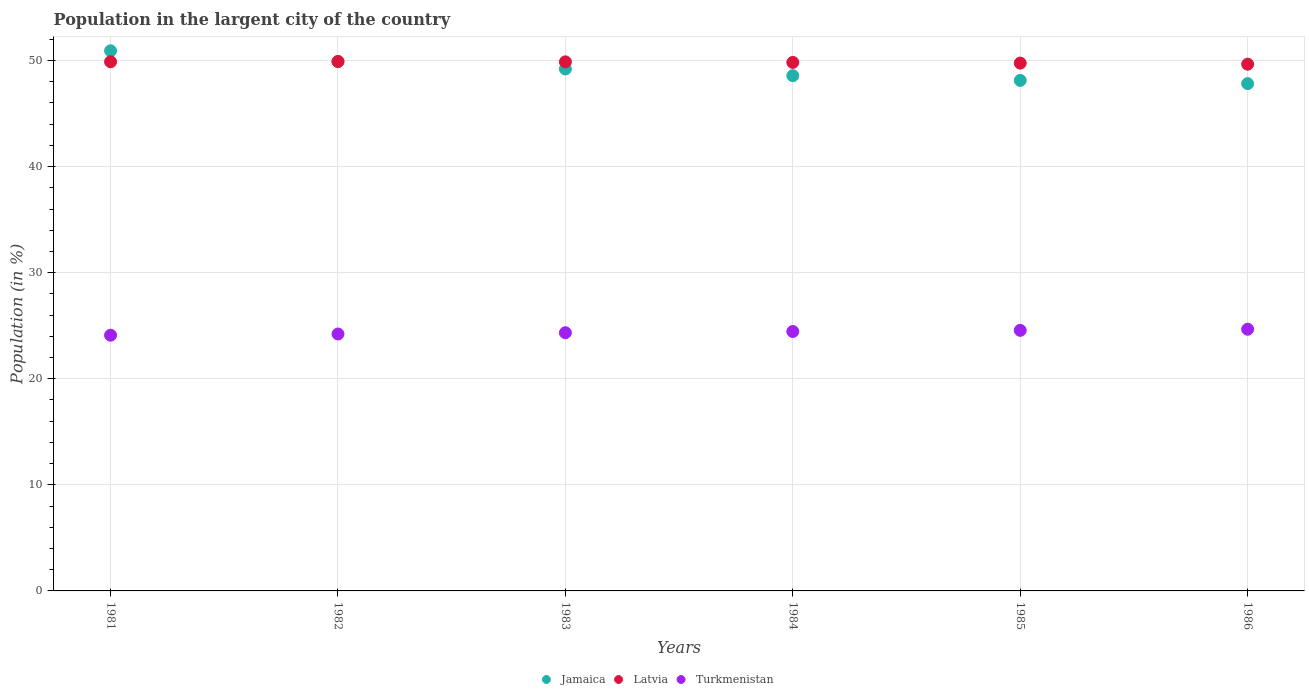How many different coloured dotlines are there?
Offer a terse response. 3. Is the number of dotlines equal to the number of legend labels?
Your response must be concise. Yes. What is the percentage of population in the largent city in Jamaica in 1986?
Offer a very short reply. 47.83. Across all years, what is the maximum percentage of population in the largent city in Turkmenistan?
Give a very brief answer. 24.67. Across all years, what is the minimum percentage of population in the largent city in Turkmenistan?
Provide a succinct answer. 24.11. What is the total percentage of population in the largent city in Latvia in the graph?
Give a very brief answer. 298.92. What is the difference between the percentage of population in the largent city in Turkmenistan in 1983 and that in 1986?
Give a very brief answer. -0.33. What is the difference between the percentage of population in the largent city in Jamaica in 1983 and the percentage of population in the largent city in Latvia in 1986?
Your response must be concise. -0.45. What is the average percentage of population in the largent city in Jamaica per year?
Give a very brief answer. 49.09. In the year 1984, what is the difference between the percentage of population in the largent city in Turkmenistan and percentage of population in the largent city in Latvia?
Keep it short and to the point. -25.37. What is the ratio of the percentage of population in the largent city in Jamaica in 1981 to that in 1982?
Give a very brief answer. 1.02. Is the percentage of population in the largent city in Jamaica in 1982 less than that in 1983?
Offer a terse response. No. Is the difference between the percentage of population in the largent city in Turkmenistan in 1983 and 1984 greater than the difference between the percentage of population in the largent city in Latvia in 1983 and 1984?
Provide a short and direct response. No. What is the difference between the highest and the second highest percentage of population in the largent city in Latvia?
Offer a terse response. 0.03. What is the difference between the highest and the lowest percentage of population in the largent city in Jamaica?
Your answer should be very brief. 3.09. In how many years, is the percentage of population in the largent city in Turkmenistan greater than the average percentage of population in the largent city in Turkmenistan taken over all years?
Your answer should be very brief. 3. Is it the case that in every year, the sum of the percentage of population in the largent city in Jamaica and percentage of population in the largent city in Latvia  is greater than the percentage of population in the largent city in Turkmenistan?
Your answer should be compact. Yes. Does the percentage of population in the largent city in Jamaica monotonically increase over the years?
Your response must be concise. No. Is the percentage of population in the largent city in Jamaica strictly greater than the percentage of population in the largent city in Turkmenistan over the years?
Ensure brevity in your answer.  Yes. How many years are there in the graph?
Your answer should be compact. 6. Are the values on the major ticks of Y-axis written in scientific E-notation?
Your answer should be compact. No. Does the graph contain grids?
Make the answer very short. Yes. Where does the legend appear in the graph?
Your answer should be compact. Bottom center. How many legend labels are there?
Provide a succinct answer. 3. How are the legend labels stacked?
Provide a short and direct response. Horizontal. What is the title of the graph?
Your response must be concise. Population in the largent city of the country. Does "Small states" appear as one of the legend labels in the graph?
Your answer should be very brief. No. What is the label or title of the X-axis?
Your answer should be very brief. Years. What is the Population (in %) in Jamaica in 1981?
Offer a terse response. 50.92. What is the Population (in %) of Latvia in 1981?
Provide a short and direct response. 49.89. What is the Population (in %) in Turkmenistan in 1981?
Keep it short and to the point. 24.11. What is the Population (in %) in Jamaica in 1982?
Keep it short and to the point. 49.9. What is the Population (in %) in Latvia in 1982?
Give a very brief answer. 49.91. What is the Population (in %) in Turkmenistan in 1982?
Give a very brief answer. 24.22. What is the Population (in %) in Jamaica in 1983?
Give a very brief answer. 49.21. What is the Population (in %) in Latvia in 1983?
Ensure brevity in your answer.  49.88. What is the Population (in %) of Turkmenistan in 1983?
Your answer should be very brief. 24.34. What is the Population (in %) in Jamaica in 1984?
Keep it short and to the point. 48.57. What is the Population (in %) in Latvia in 1984?
Keep it short and to the point. 49.82. What is the Population (in %) of Turkmenistan in 1984?
Ensure brevity in your answer.  24.46. What is the Population (in %) of Jamaica in 1985?
Provide a succinct answer. 48.13. What is the Population (in %) of Latvia in 1985?
Your response must be concise. 49.76. What is the Population (in %) of Turkmenistan in 1985?
Your response must be concise. 24.56. What is the Population (in %) of Jamaica in 1986?
Provide a short and direct response. 47.83. What is the Population (in %) of Latvia in 1986?
Offer a terse response. 49.66. What is the Population (in %) in Turkmenistan in 1986?
Offer a terse response. 24.67. Across all years, what is the maximum Population (in %) of Jamaica?
Your answer should be very brief. 50.92. Across all years, what is the maximum Population (in %) in Latvia?
Make the answer very short. 49.91. Across all years, what is the maximum Population (in %) in Turkmenistan?
Keep it short and to the point. 24.67. Across all years, what is the minimum Population (in %) of Jamaica?
Your answer should be compact. 47.83. Across all years, what is the minimum Population (in %) of Latvia?
Ensure brevity in your answer.  49.66. Across all years, what is the minimum Population (in %) in Turkmenistan?
Offer a terse response. 24.11. What is the total Population (in %) of Jamaica in the graph?
Your answer should be very brief. 294.55. What is the total Population (in %) of Latvia in the graph?
Make the answer very short. 298.92. What is the total Population (in %) of Turkmenistan in the graph?
Your answer should be very brief. 146.36. What is the difference between the Population (in %) in Jamaica in 1981 and that in 1982?
Provide a succinct answer. 1.02. What is the difference between the Population (in %) in Latvia in 1981 and that in 1982?
Provide a succinct answer. -0.03. What is the difference between the Population (in %) in Turkmenistan in 1981 and that in 1982?
Offer a very short reply. -0.12. What is the difference between the Population (in %) in Jamaica in 1981 and that in 1983?
Give a very brief answer. 1.71. What is the difference between the Population (in %) of Latvia in 1981 and that in 1983?
Offer a terse response. 0.01. What is the difference between the Population (in %) of Turkmenistan in 1981 and that in 1983?
Provide a succinct answer. -0.23. What is the difference between the Population (in %) of Jamaica in 1981 and that in 1984?
Give a very brief answer. 2.35. What is the difference between the Population (in %) in Latvia in 1981 and that in 1984?
Your answer should be very brief. 0.06. What is the difference between the Population (in %) of Turkmenistan in 1981 and that in 1984?
Your response must be concise. -0.35. What is the difference between the Population (in %) in Jamaica in 1981 and that in 1985?
Keep it short and to the point. 2.79. What is the difference between the Population (in %) of Latvia in 1981 and that in 1985?
Your answer should be very brief. 0.13. What is the difference between the Population (in %) in Turkmenistan in 1981 and that in 1985?
Provide a succinct answer. -0.46. What is the difference between the Population (in %) in Jamaica in 1981 and that in 1986?
Offer a terse response. 3.09. What is the difference between the Population (in %) of Latvia in 1981 and that in 1986?
Offer a very short reply. 0.23. What is the difference between the Population (in %) in Turkmenistan in 1981 and that in 1986?
Give a very brief answer. -0.57. What is the difference between the Population (in %) of Jamaica in 1982 and that in 1983?
Provide a short and direct response. 0.69. What is the difference between the Population (in %) of Latvia in 1982 and that in 1983?
Ensure brevity in your answer.  0.04. What is the difference between the Population (in %) in Turkmenistan in 1982 and that in 1983?
Offer a terse response. -0.12. What is the difference between the Population (in %) of Jamaica in 1982 and that in 1984?
Your response must be concise. 1.33. What is the difference between the Population (in %) in Latvia in 1982 and that in 1984?
Ensure brevity in your answer.  0.09. What is the difference between the Population (in %) of Turkmenistan in 1982 and that in 1984?
Ensure brevity in your answer.  -0.23. What is the difference between the Population (in %) of Jamaica in 1982 and that in 1985?
Your answer should be compact. 1.77. What is the difference between the Population (in %) of Latvia in 1982 and that in 1985?
Your answer should be very brief. 0.15. What is the difference between the Population (in %) in Turkmenistan in 1982 and that in 1985?
Your response must be concise. -0.34. What is the difference between the Population (in %) of Jamaica in 1982 and that in 1986?
Your answer should be very brief. 2.08. What is the difference between the Population (in %) in Latvia in 1982 and that in 1986?
Give a very brief answer. 0.25. What is the difference between the Population (in %) in Turkmenistan in 1982 and that in 1986?
Provide a succinct answer. -0.45. What is the difference between the Population (in %) of Jamaica in 1983 and that in 1984?
Offer a very short reply. 0.63. What is the difference between the Population (in %) of Latvia in 1983 and that in 1984?
Your response must be concise. 0.05. What is the difference between the Population (in %) in Turkmenistan in 1983 and that in 1984?
Offer a very short reply. -0.12. What is the difference between the Population (in %) in Jamaica in 1983 and that in 1985?
Ensure brevity in your answer.  1.08. What is the difference between the Population (in %) in Latvia in 1983 and that in 1985?
Your response must be concise. 0.12. What is the difference between the Population (in %) of Turkmenistan in 1983 and that in 1985?
Your answer should be very brief. -0.22. What is the difference between the Population (in %) of Jamaica in 1983 and that in 1986?
Offer a terse response. 1.38. What is the difference between the Population (in %) in Latvia in 1983 and that in 1986?
Your answer should be compact. 0.22. What is the difference between the Population (in %) in Turkmenistan in 1983 and that in 1986?
Make the answer very short. -0.33. What is the difference between the Population (in %) of Jamaica in 1984 and that in 1985?
Offer a very short reply. 0.45. What is the difference between the Population (in %) in Latvia in 1984 and that in 1985?
Offer a very short reply. 0.06. What is the difference between the Population (in %) of Turkmenistan in 1984 and that in 1985?
Your answer should be compact. -0.11. What is the difference between the Population (in %) of Jamaica in 1984 and that in 1986?
Make the answer very short. 0.75. What is the difference between the Population (in %) of Latvia in 1984 and that in 1986?
Your response must be concise. 0.17. What is the difference between the Population (in %) in Turkmenistan in 1984 and that in 1986?
Offer a very short reply. -0.21. What is the difference between the Population (in %) in Jamaica in 1985 and that in 1986?
Ensure brevity in your answer.  0.3. What is the difference between the Population (in %) in Latvia in 1985 and that in 1986?
Keep it short and to the point. 0.1. What is the difference between the Population (in %) of Turkmenistan in 1985 and that in 1986?
Offer a terse response. -0.11. What is the difference between the Population (in %) in Jamaica in 1981 and the Population (in %) in Latvia in 1982?
Your response must be concise. 1.01. What is the difference between the Population (in %) of Jamaica in 1981 and the Population (in %) of Turkmenistan in 1982?
Make the answer very short. 26.7. What is the difference between the Population (in %) of Latvia in 1981 and the Population (in %) of Turkmenistan in 1982?
Make the answer very short. 25.66. What is the difference between the Population (in %) in Jamaica in 1981 and the Population (in %) in Latvia in 1983?
Ensure brevity in your answer.  1.04. What is the difference between the Population (in %) in Jamaica in 1981 and the Population (in %) in Turkmenistan in 1983?
Your answer should be compact. 26.58. What is the difference between the Population (in %) in Latvia in 1981 and the Population (in %) in Turkmenistan in 1983?
Your answer should be very brief. 25.55. What is the difference between the Population (in %) of Jamaica in 1981 and the Population (in %) of Latvia in 1984?
Your response must be concise. 1.1. What is the difference between the Population (in %) of Jamaica in 1981 and the Population (in %) of Turkmenistan in 1984?
Provide a succinct answer. 26.46. What is the difference between the Population (in %) in Latvia in 1981 and the Population (in %) in Turkmenistan in 1984?
Your answer should be very brief. 25.43. What is the difference between the Population (in %) in Jamaica in 1981 and the Population (in %) in Latvia in 1985?
Keep it short and to the point. 1.16. What is the difference between the Population (in %) in Jamaica in 1981 and the Population (in %) in Turkmenistan in 1985?
Offer a very short reply. 26.36. What is the difference between the Population (in %) of Latvia in 1981 and the Population (in %) of Turkmenistan in 1985?
Ensure brevity in your answer.  25.32. What is the difference between the Population (in %) of Jamaica in 1981 and the Population (in %) of Latvia in 1986?
Your answer should be compact. 1.26. What is the difference between the Population (in %) in Jamaica in 1981 and the Population (in %) in Turkmenistan in 1986?
Offer a very short reply. 26.25. What is the difference between the Population (in %) of Latvia in 1981 and the Population (in %) of Turkmenistan in 1986?
Offer a terse response. 25.22. What is the difference between the Population (in %) in Jamaica in 1982 and the Population (in %) in Latvia in 1983?
Offer a terse response. 0.02. What is the difference between the Population (in %) in Jamaica in 1982 and the Population (in %) in Turkmenistan in 1983?
Offer a very short reply. 25.56. What is the difference between the Population (in %) of Latvia in 1982 and the Population (in %) of Turkmenistan in 1983?
Provide a succinct answer. 25.57. What is the difference between the Population (in %) of Jamaica in 1982 and the Population (in %) of Latvia in 1984?
Your answer should be very brief. 0.08. What is the difference between the Population (in %) in Jamaica in 1982 and the Population (in %) in Turkmenistan in 1984?
Your response must be concise. 25.44. What is the difference between the Population (in %) in Latvia in 1982 and the Population (in %) in Turkmenistan in 1984?
Your answer should be compact. 25.46. What is the difference between the Population (in %) in Jamaica in 1982 and the Population (in %) in Latvia in 1985?
Provide a short and direct response. 0.14. What is the difference between the Population (in %) in Jamaica in 1982 and the Population (in %) in Turkmenistan in 1985?
Give a very brief answer. 25.34. What is the difference between the Population (in %) of Latvia in 1982 and the Population (in %) of Turkmenistan in 1985?
Offer a very short reply. 25.35. What is the difference between the Population (in %) of Jamaica in 1982 and the Population (in %) of Latvia in 1986?
Ensure brevity in your answer.  0.24. What is the difference between the Population (in %) in Jamaica in 1982 and the Population (in %) in Turkmenistan in 1986?
Your answer should be compact. 25.23. What is the difference between the Population (in %) of Latvia in 1982 and the Population (in %) of Turkmenistan in 1986?
Provide a short and direct response. 25.24. What is the difference between the Population (in %) in Jamaica in 1983 and the Population (in %) in Latvia in 1984?
Ensure brevity in your answer.  -0.62. What is the difference between the Population (in %) of Jamaica in 1983 and the Population (in %) of Turkmenistan in 1984?
Give a very brief answer. 24.75. What is the difference between the Population (in %) in Latvia in 1983 and the Population (in %) in Turkmenistan in 1984?
Provide a short and direct response. 25.42. What is the difference between the Population (in %) of Jamaica in 1983 and the Population (in %) of Latvia in 1985?
Provide a succinct answer. -0.55. What is the difference between the Population (in %) of Jamaica in 1983 and the Population (in %) of Turkmenistan in 1985?
Offer a very short reply. 24.64. What is the difference between the Population (in %) of Latvia in 1983 and the Population (in %) of Turkmenistan in 1985?
Offer a very short reply. 25.31. What is the difference between the Population (in %) in Jamaica in 1983 and the Population (in %) in Latvia in 1986?
Provide a succinct answer. -0.45. What is the difference between the Population (in %) of Jamaica in 1983 and the Population (in %) of Turkmenistan in 1986?
Offer a terse response. 24.54. What is the difference between the Population (in %) in Latvia in 1983 and the Population (in %) in Turkmenistan in 1986?
Provide a short and direct response. 25.21. What is the difference between the Population (in %) of Jamaica in 1984 and the Population (in %) of Latvia in 1985?
Make the answer very short. -1.19. What is the difference between the Population (in %) of Jamaica in 1984 and the Population (in %) of Turkmenistan in 1985?
Give a very brief answer. 24.01. What is the difference between the Population (in %) in Latvia in 1984 and the Population (in %) in Turkmenistan in 1985?
Give a very brief answer. 25.26. What is the difference between the Population (in %) in Jamaica in 1984 and the Population (in %) in Latvia in 1986?
Provide a short and direct response. -1.08. What is the difference between the Population (in %) of Jamaica in 1984 and the Population (in %) of Turkmenistan in 1986?
Provide a short and direct response. 23.9. What is the difference between the Population (in %) of Latvia in 1984 and the Population (in %) of Turkmenistan in 1986?
Ensure brevity in your answer.  25.15. What is the difference between the Population (in %) in Jamaica in 1985 and the Population (in %) in Latvia in 1986?
Provide a short and direct response. -1.53. What is the difference between the Population (in %) of Jamaica in 1985 and the Population (in %) of Turkmenistan in 1986?
Provide a short and direct response. 23.45. What is the difference between the Population (in %) in Latvia in 1985 and the Population (in %) in Turkmenistan in 1986?
Provide a short and direct response. 25.09. What is the average Population (in %) in Jamaica per year?
Your answer should be compact. 49.09. What is the average Population (in %) in Latvia per year?
Provide a short and direct response. 49.82. What is the average Population (in %) of Turkmenistan per year?
Ensure brevity in your answer.  24.39. In the year 1981, what is the difference between the Population (in %) in Jamaica and Population (in %) in Latvia?
Your response must be concise. 1.03. In the year 1981, what is the difference between the Population (in %) of Jamaica and Population (in %) of Turkmenistan?
Offer a terse response. 26.81. In the year 1981, what is the difference between the Population (in %) of Latvia and Population (in %) of Turkmenistan?
Your answer should be very brief. 25.78. In the year 1982, what is the difference between the Population (in %) of Jamaica and Population (in %) of Latvia?
Keep it short and to the point. -0.01. In the year 1982, what is the difference between the Population (in %) of Jamaica and Population (in %) of Turkmenistan?
Give a very brief answer. 25.68. In the year 1982, what is the difference between the Population (in %) in Latvia and Population (in %) in Turkmenistan?
Offer a terse response. 25.69. In the year 1983, what is the difference between the Population (in %) of Jamaica and Population (in %) of Latvia?
Ensure brevity in your answer.  -0.67. In the year 1983, what is the difference between the Population (in %) in Jamaica and Population (in %) in Turkmenistan?
Provide a short and direct response. 24.87. In the year 1983, what is the difference between the Population (in %) in Latvia and Population (in %) in Turkmenistan?
Offer a very short reply. 25.54. In the year 1984, what is the difference between the Population (in %) in Jamaica and Population (in %) in Latvia?
Your answer should be very brief. -1.25. In the year 1984, what is the difference between the Population (in %) in Jamaica and Population (in %) in Turkmenistan?
Provide a succinct answer. 24.12. In the year 1984, what is the difference between the Population (in %) in Latvia and Population (in %) in Turkmenistan?
Your response must be concise. 25.37. In the year 1985, what is the difference between the Population (in %) in Jamaica and Population (in %) in Latvia?
Keep it short and to the point. -1.63. In the year 1985, what is the difference between the Population (in %) in Jamaica and Population (in %) in Turkmenistan?
Keep it short and to the point. 23.56. In the year 1985, what is the difference between the Population (in %) in Latvia and Population (in %) in Turkmenistan?
Ensure brevity in your answer.  25.19. In the year 1986, what is the difference between the Population (in %) in Jamaica and Population (in %) in Latvia?
Ensure brevity in your answer.  -1.83. In the year 1986, what is the difference between the Population (in %) of Jamaica and Population (in %) of Turkmenistan?
Keep it short and to the point. 23.15. In the year 1986, what is the difference between the Population (in %) in Latvia and Population (in %) in Turkmenistan?
Make the answer very short. 24.99. What is the ratio of the Population (in %) of Jamaica in 1981 to that in 1982?
Provide a short and direct response. 1.02. What is the ratio of the Population (in %) in Jamaica in 1981 to that in 1983?
Provide a short and direct response. 1.03. What is the ratio of the Population (in %) in Latvia in 1981 to that in 1983?
Your response must be concise. 1. What is the ratio of the Population (in %) of Jamaica in 1981 to that in 1984?
Offer a very short reply. 1.05. What is the ratio of the Population (in %) of Turkmenistan in 1981 to that in 1984?
Ensure brevity in your answer.  0.99. What is the ratio of the Population (in %) in Jamaica in 1981 to that in 1985?
Offer a very short reply. 1.06. What is the ratio of the Population (in %) of Latvia in 1981 to that in 1985?
Your answer should be very brief. 1. What is the ratio of the Population (in %) in Turkmenistan in 1981 to that in 1985?
Make the answer very short. 0.98. What is the ratio of the Population (in %) in Jamaica in 1981 to that in 1986?
Offer a very short reply. 1.06. What is the ratio of the Population (in %) in Turkmenistan in 1981 to that in 1986?
Keep it short and to the point. 0.98. What is the ratio of the Population (in %) in Jamaica in 1982 to that in 1983?
Keep it short and to the point. 1.01. What is the ratio of the Population (in %) of Latvia in 1982 to that in 1983?
Provide a short and direct response. 1. What is the ratio of the Population (in %) in Turkmenistan in 1982 to that in 1983?
Keep it short and to the point. 1. What is the ratio of the Population (in %) in Jamaica in 1982 to that in 1984?
Offer a very short reply. 1.03. What is the ratio of the Population (in %) in Latvia in 1982 to that in 1984?
Your answer should be very brief. 1. What is the ratio of the Population (in %) in Jamaica in 1982 to that in 1985?
Your answer should be very brief. 1.04. What is the ratio of the Population (in %) in Turkmenistan in 1982 to that in 1985?
Your answer should be compact. 0.99. What is the ratio of the Population (in %) of Jamaica in 1982 to that in 1986?
Give a very brief answer. 1.04. What is the ratio of the Population (in %) in Latvia in 1982 to that in 1986?
Make the answer very short. 1.01. What is the ratio of the Population (in %) in Turkmenistan in 1982 to that in 1986?
Your answer should be very brief. 0.98. What is the ratio of the Population (in %) of Turkmenistan in 1983 to that in 1984?
Your answer should be compact. 1. What is the ratio of the Population (in %) of Jamaica in 1983 to that in 1985?
Offer a very short reply. 1.02. What is the ratio of the Population (in %) in Latvia in 1983 to that in 1985?
Give a very brief answer. 1. What is the ratio of the Population (in %) in Turkmenistan in 1983 to that in 1985?
Your answer should be compact. 0.99. What is the ratio of the Population (in %) in Jamaica in 1983 to that in 1986?
Your answer should be compact. 1.03. What is the ratio of the Population (in %) in Latvia in 1983 to that in 1986?
Give a very brief answer. 1. What is the ratio of the Population (in %) in Turkmenistan in 1983 to that in 1986?
Provide a succinct answer. 0.99. What is the ratio of the Population (in %) in Jamaica in 1984 to that in 1985?
Provide a succinct answer. 1.01. What is the ratio of the Population (in %) in Jamaica in 1984 to that in 1986?
Your answer should be very brief. 1.02. What is the ratio of the Population (in %) of Latvia in 1984 to that in 1986?
Ensure brevity in your answer.  1. What is the ratio of the Population (in %) in Jamaica in 1985 to that in 1986?
Your answer should be compact. 1.01. What is the ratio of the Population (in %) in Latvia in 1985 to that in 1986?
Give a very brief answer. 1. What is the ratio of the Population (in %) in Turkmenistan in 1985 to that in 1986?
Provide a short and direct response. 1. What is the difference between the highest and the second highest Population (in %) in Jamaica?
Offer a very short reply. 1.02. What is the difference between the highest and the second highest Population (in %) in Latvia?
Offer a very short reply. 0.03. What is the difference between the highest and the second highest Population (in %) in Turkmenistan?
Offer a terse response. 0.11. What is the difference between the highest and the lowest Population (in %) in Jamaica?
Your response must be concise. 3.09. What is the difference between the highest and the lowest Population (in %) in Latvia?
Offer a very short reply. 0.25. What is the difference between the highest and the lowest Population (in %) in Turkmenistan?
Your answer should be compact. 0.57. 